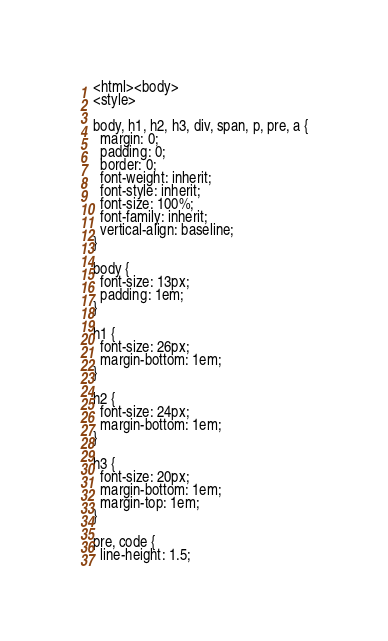Convert code to text. <code><loc_0><loc_0><loc_500><loc_500><_HTML_><html><body>
<style>

body, h1, h2, h3, div, span, p, pre, a {
  margin: 0;
  padding: 0;
  border: 0;
  font-weight: inherit;
  font-style: inherit;
  font-size: 100%;
  font-family: inherit;
  vertical-align: baseline;
}

body {
  font-size: 13px;
  padding: 1em;
}

h1 {
  font-size: 26px;
  margin-bottom: 1em;
}

h2 {
  font-size: 24px;
  margin-bottom: 1em;
}

h3 {
  font-size: 20px;
  margin-bottom: 1em;
  margin-top: 1em;
}

pre, code {
  line-height: 1.5;</code> 